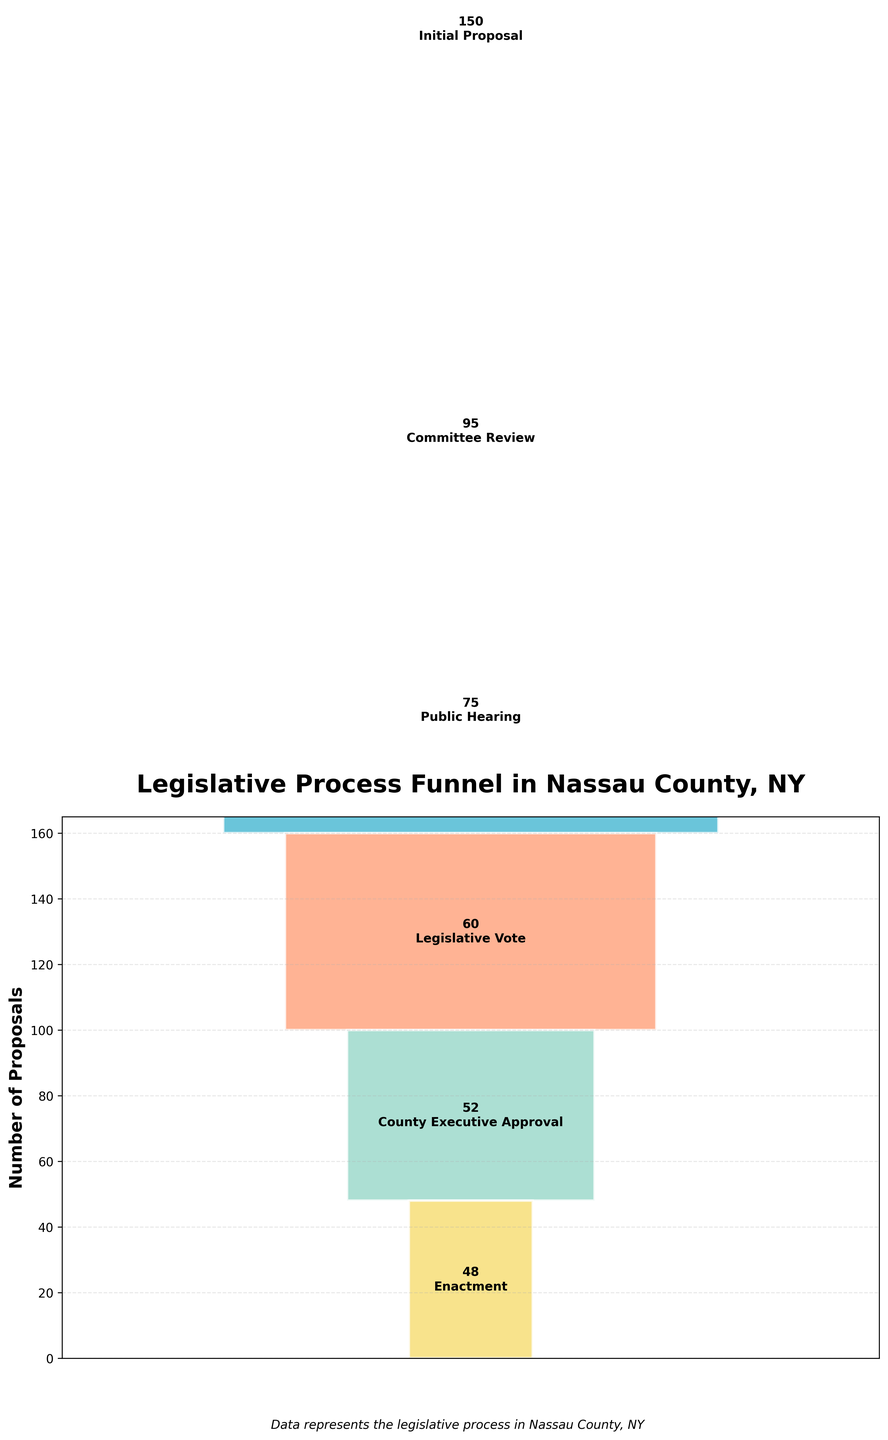What stage has the highest number of proposals? The stage with the highest number of proposals is the one at the widest part of the funnel. From the figure, this is "Initial Proposal" with 150 proposals.
Answer: Initial Proposal How many stages are depicted in the legislative process funnel? The number of stages is equal to the number of different segments in the funnel. Counting each segment, there are 6 stages.
Answer: 6 What is the title of the funnel chart? The title is usually displayed prominently at the top of the figure. Here, it is "Legislative Process Funnel in Nassau County, NY".
Answer: Legislative Process Funnel in Nassau County, NY Which stage has the fewest number of proposals? The stage with the fewest number of proposals is the one at the narrowest part of the funnel. From the figure, this is "Enactment" with 48 proposals.
Answer: Enactment What stage comes after the "Legislative Vote" in the process? By following the order of the funnel from top to bottom, we see that "County Executive Approval" comes immediately after "Legislative Vote".
Answer: County Executive Approval What is the total number of proposals that did not reach the "Enactment" stage? Sum the difference between each stage and the next. (150 - 95) + (95 - 75) + (75 - 60) + (60 - 52) + (52 - 48) = 55 + 20 + 15 + 8 + 4. The total is 102.
Answer: 102 Which stage has the second-highest number of proposals? The second-highest number of proposals is at the second-widest part of the funnel. The "Committee Review" stage has 95 proposals, following "Initial Proposal".
Answer: Committee Review How does the number of proposals in "Committee Review" compare to "Public Hearing"? By comparing the numbers at these stages, "Committee Review" has 95 proposals while "Public Hearing" has 75. 95 is greater than 75.
Answer: Greater What percentage of initial proposals reach the "Legislative Vote" stage? To find this, divide the number of proposals in "Legislative Vote" by "Initial Proposal" and multiply by 100: (60 / 150) * 100 = 40%.
Answer: 40% What is the overall drop from "Initial Proposal" to "Enactment" in terms of number of proposals? Subtract the number of proposals at "Enactment" from "Initial Proposal": 150 - 48 = 102.
Answer: 102 Summarize the trends displayed by the funnel chart. As proposals move through the legislative process, the number of proposals decreases at each subsequent stage, indicating a filtering process where proposals get evaluated and possibly rejected at each stage.
Answer: The number of proposals decreases at each stage 